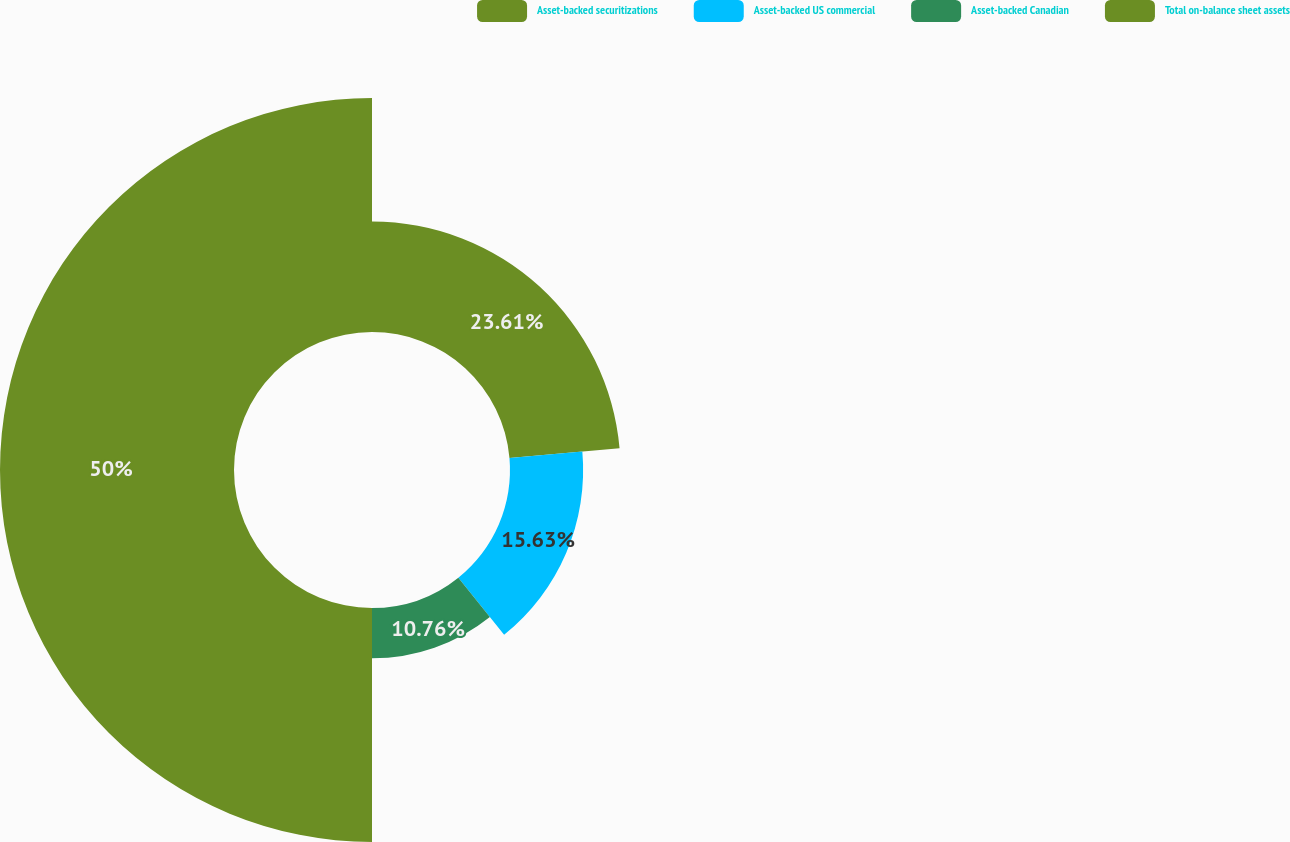<chart> <loc_0><loc_0><loc_500><loc_500><pie_chart><fcel>Asset-backed securitizations<fcel>Asset-backed US commercial<fcel>Asset-backed Canadian<fcel>Total on-balance sheet assets<nl><fcel>23.61%<fcel>15.63%<fcel>10.76%<fcel>50.0%<nl></chart> 